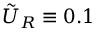<formula> <loc_0><loc_0><loc_500><loc_500>\tilde { U } _ { R } \equiv 0 . 1</formula> 